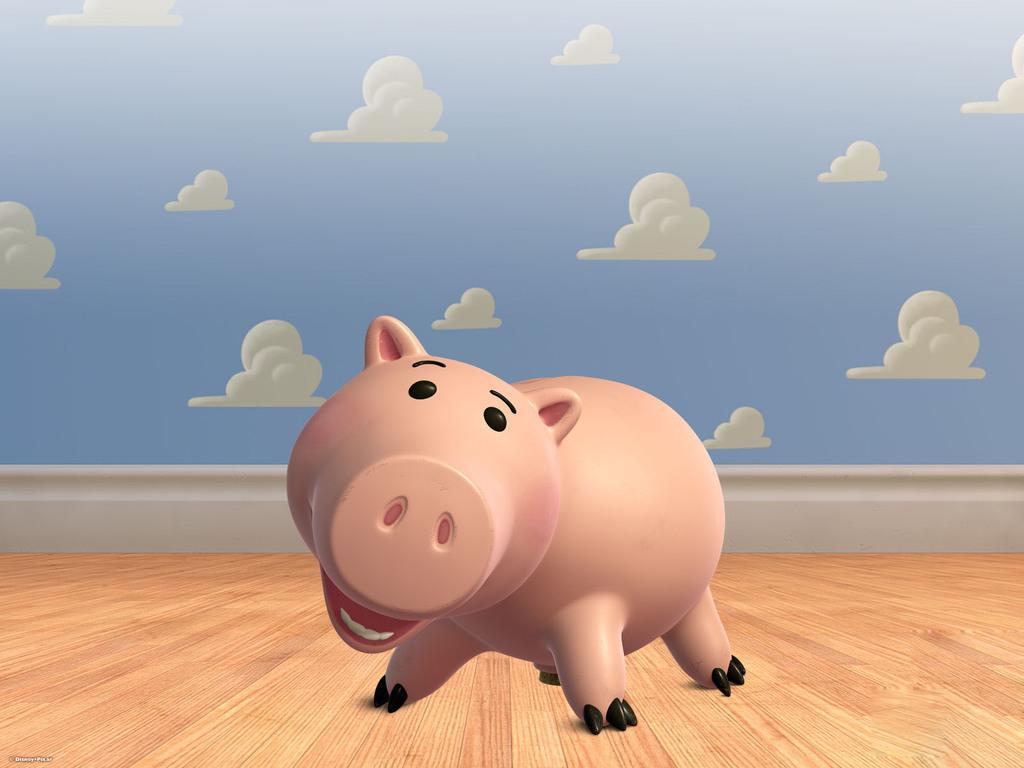Please provide a concise description of this image. Here in this picture we can see an animated pig present on the floor over there and we can also see clouds over there. 